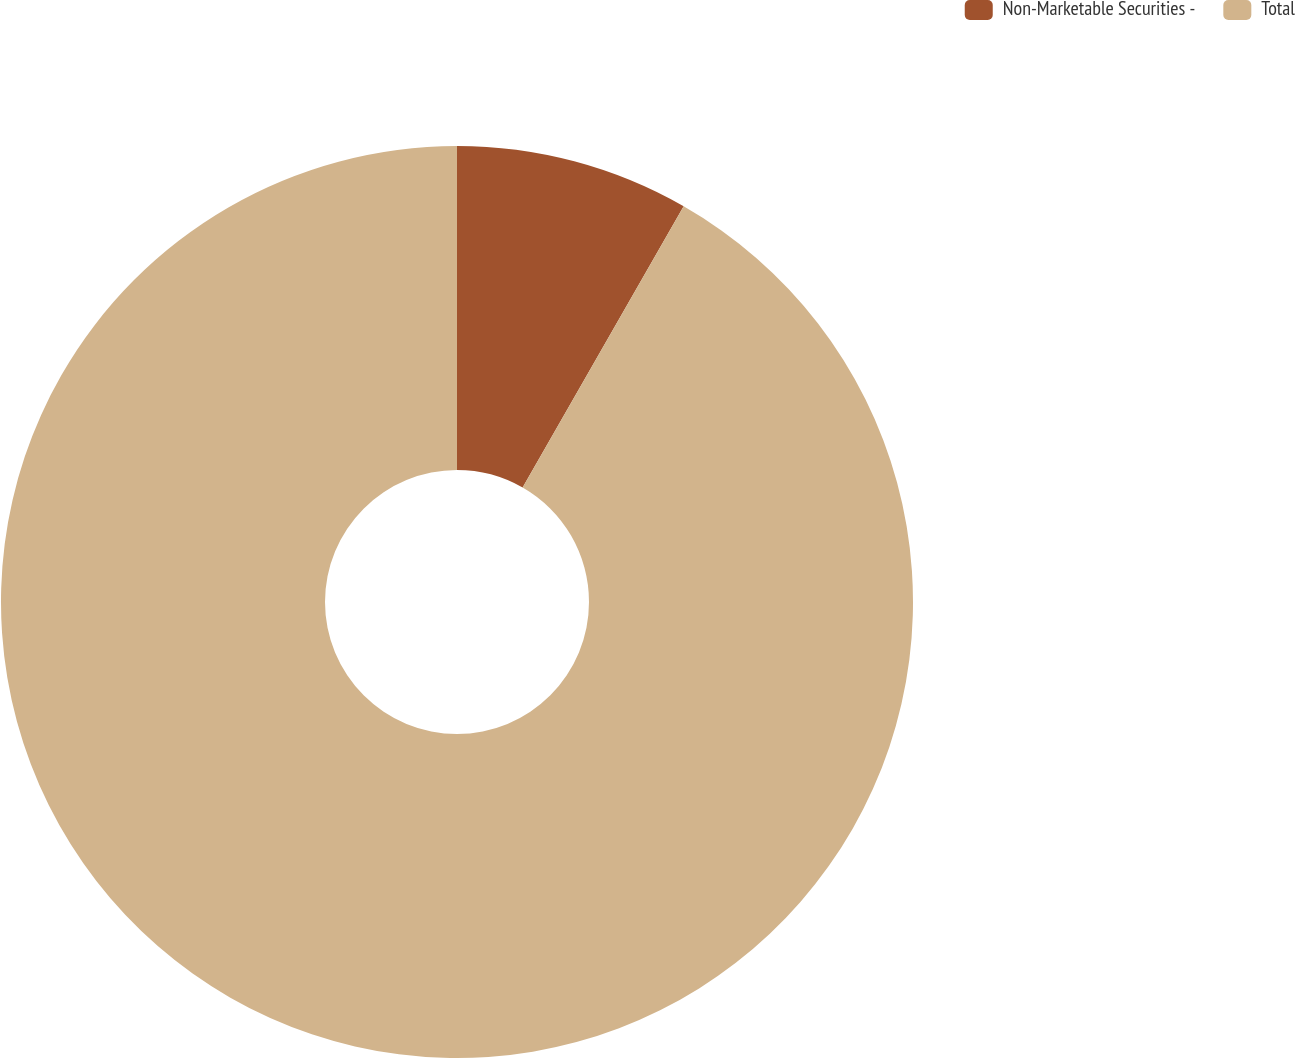Convert chart to OTSL. <chart><loc_0><loc_0><loc_500><loc_500><pie_chart><fcel>Non-Marketable Securities -<fcel>Total<nl><fcel>8.28%<fcel>91.72%<nl></chart> 